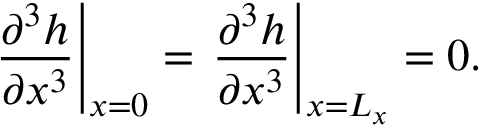<formula> <loc_0><loc_0><loc_500><loc_500>\frac { \partial ^ { 3 } h } { \partial x ^ { 3 } } \right | _ { x = 0 } = \frac { \partial ^ { 3 } h } { \partial x ^ { 3 } } \right | _ { x = L _ { x } } = 0 .</formula> 